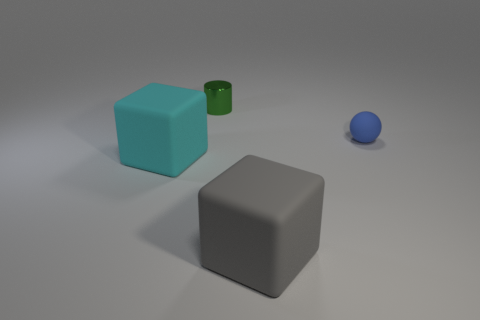Does the large gray block have the same material as the small thing behind the blue ball?
Your response must be concise. No. Are there fewer large brown shiny cubes than gray matte blocks?
Give a very brief answer. Yes. Are there any other things that are the same color as the rubber ball?
Keep it short and to the point. No. The big cyan object that is the same material as the blue object is what shape?
Your answer should be compact. Cube. What number of small green cylinders are on the right side of the tiny thing that is left of the rubber thing right of the large gray thing?
Your answer should be very brief. 0. What is the shape of the rubber object that is behind the gray object and to the left of the blue matte object?
Ensure brevity in your answer.  Cube. Is the number of green shiny things that are behind the small metallic thing less than the number of big blue shiny cylinders?
Provide a succinct answer. No. What number of large objects are either metallic balls or matte balls?
Offer a very short reply. 0. The cyan block is what size?
Offer a terse response. Large. Are there any other things that have the same material as the tiny green cylinder?
Offer a terse response. No. 